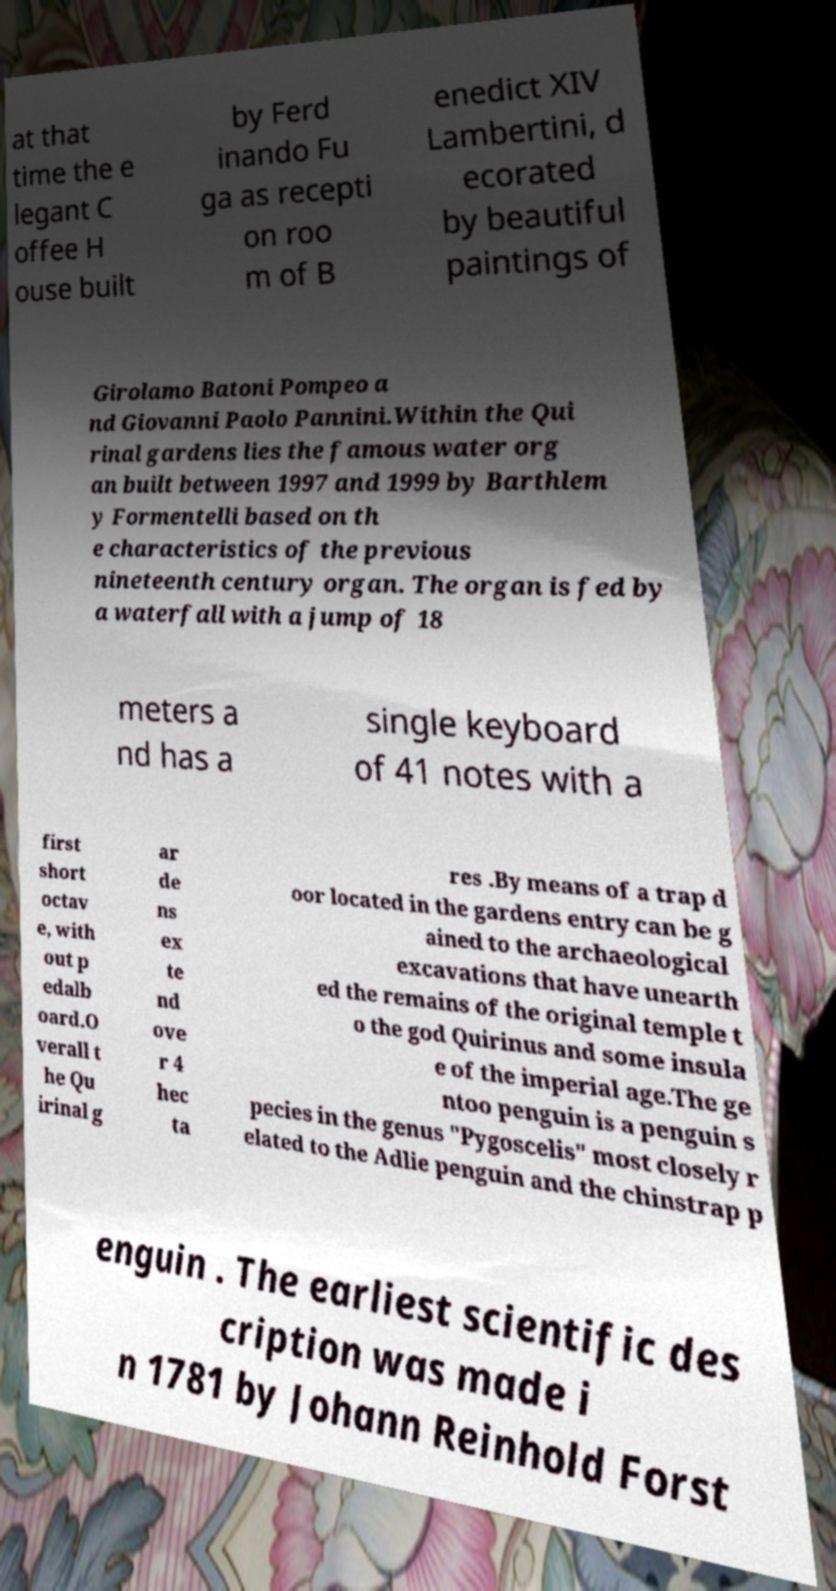Can you read and provide the text displayed in the image?This photo seems to have some interesting text. Can you extract and type it out for me? at that time the e legant C offee H ouse built by Ferd inando Fu ga as recepti on roo m of B enedict XIV Lambertini, d ecorated by beautiful paintings of Girolamo Batoni Pompeo a nd Giovanni Paolo Pannini.Within the Qui rinal gardens lies the famous water org an built between 1997 and 1999 by Barthlem y Formentelli based on th e characteristics of the previous nineteenth century organ. The organ is fed by a waterfall with a jump of 18 meters a nd has a single keyboard of 41 notes with a first short octav e, with out p edalb oard.O verall t he Qu irinal g ar de ns ex te nd ove r 4 hec ta res .By means of a trap d oor located in the gardens entry can be g ained to the archaeological excavations that have unearth ed the remains of the original temple t o the god Quirinus and some insula e of the imperial age.The ge ntoo penguin is a penguin s pecies in the genus "Pygoscelis" most closely r elated to the Adlie penguin and the chinstrap p enguin . The earliest scientific des cription was made i n 1781 by Johann Reinhold Forst 